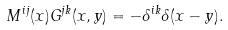Convert formula to latex. <formula><loc_0><loc_0><loc_500><loc_500>M ^ { i j } ( x ) G ^ { j k } ( x , y ) = - \delta ^ { i k } \delta ( x - y ) .</formula> 